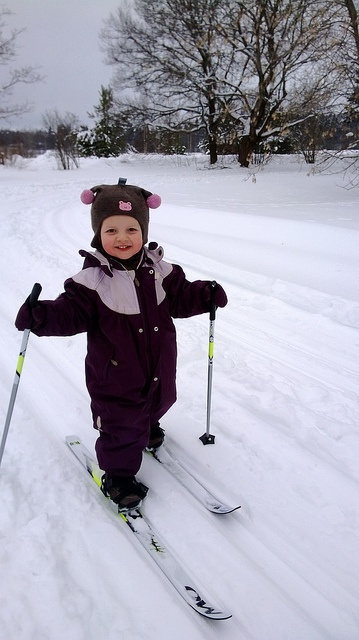Describe the objects in this image and their specific colors. I can see people in darkgray, black, brown, and lavender tones and skis in darkgray, lavender, and lightgray tones in this image. 